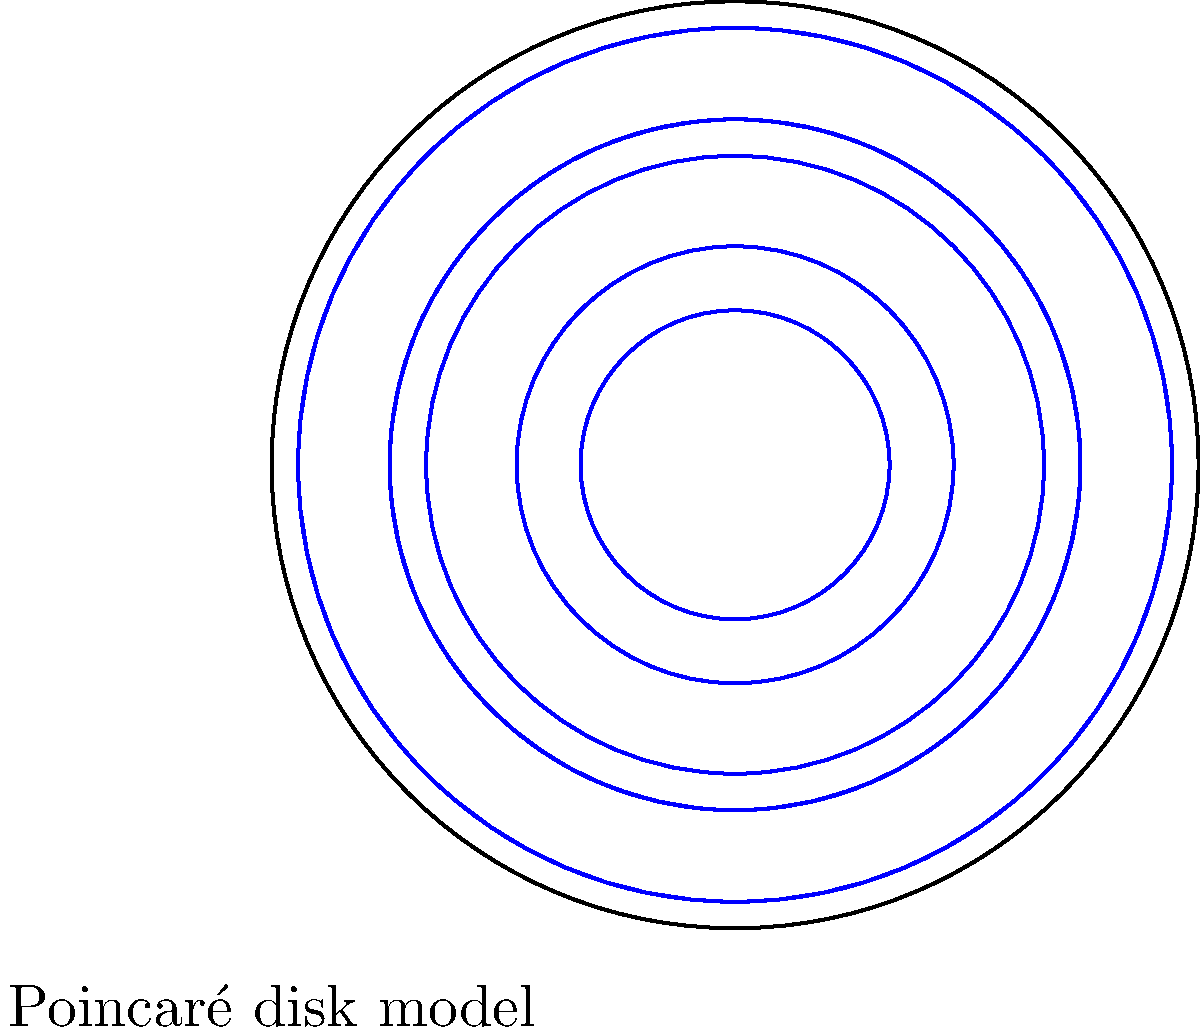In the Poincaré disk model of hyperbolic geometry shown above, what happens to the curvature of space as you approach the boundary of the disk? How does this relate to the concept of ideal points in hyperbolic geometry? To understand the curvature of space in the Poincaré disk model and its relation to ideal points, let's break it down step-by-step:

1. The Poincaré disk model represents the entire hyperbolic plane as the interior of a circular disk.

2. In this model, straight lines in hyperbolic geometry are represented by either:
   a) Diameters of the disk
   b) Circular arcs that intersect the boundary of the disk at right angles

3. As we move towards the boundary of the disk:
   a) The density of the blue arcs increases
   b) The size of the hyperbolic triangles formed by these arcs decreases

4. This increasing density and decreasing size indicate that the curvature of space becomes more extreme as we approach the boundary.

5. Mathematically, the metric in the Poincaré disk model is given by:

   $$ds^2 = \frac{4(dx^2 + dy^2)}{(1-x^2-y^2)^2}$$

   where $(x,y)$ are the Euclidean coordinates in the unit disk.

6. As $(x,y)$ approaches the boundary where $x^2+y^2=1$, the denominator approaches zero, causing the metric to approach infinity.

7. This means that distances in the hyperbolic plane become infinitely large near the boundary of the Poincaré disk.

8. The boundary of the disk itself represents the "points at infinity" or "ideal points" in hyperbolic geometry.

9. These ideal points are not actually part of the hyperbolic plane but represent endpoints of infinitely long geodesics.

10. In the context of hyperbolic geometry, parallel lines meet at ideal points, which is visualized in the Poincaré disk model as lines (circular arcs) meeting at the boundary of the disk.

Therefore, the increasing curvature near the boundary of the Poincaré disk model illustrates how ideal points in hyperbolic geometry represent infinitely distant locations where parallel lines meet.
Answer: The curvature increases towards infinity as you approach the boundary, which represents ideal points where parallel lines meet at infinity in hyperbolic geometry. 